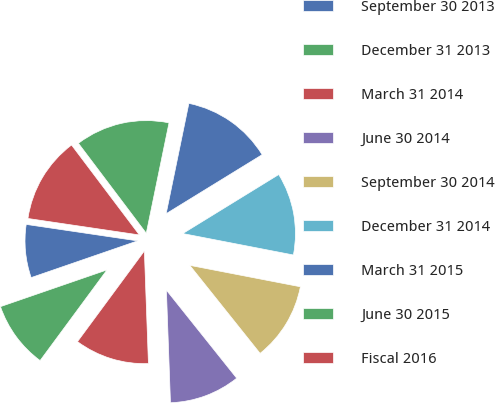<chart> <loc_0><loc_0><loc_500><loc_500><pie_chart><fcel>September 30 2013<fcel>December 31 2013<fcel>March 31 2014<fcel>June 30 2014<fcel>September 30 2014<fcel>December 31 2014<fcel>March 31 2015<fcel>June 30 2015<fcel>Fiscal 2016<nl><fcel>7.62%<fcel>9.6%<fcel>10.69%<fcel>10.15%<fcel>11.23%<fcel>11.82%<fcel>12.99%<fcel>13.52%<fcel>12.38%<nl></chart> 